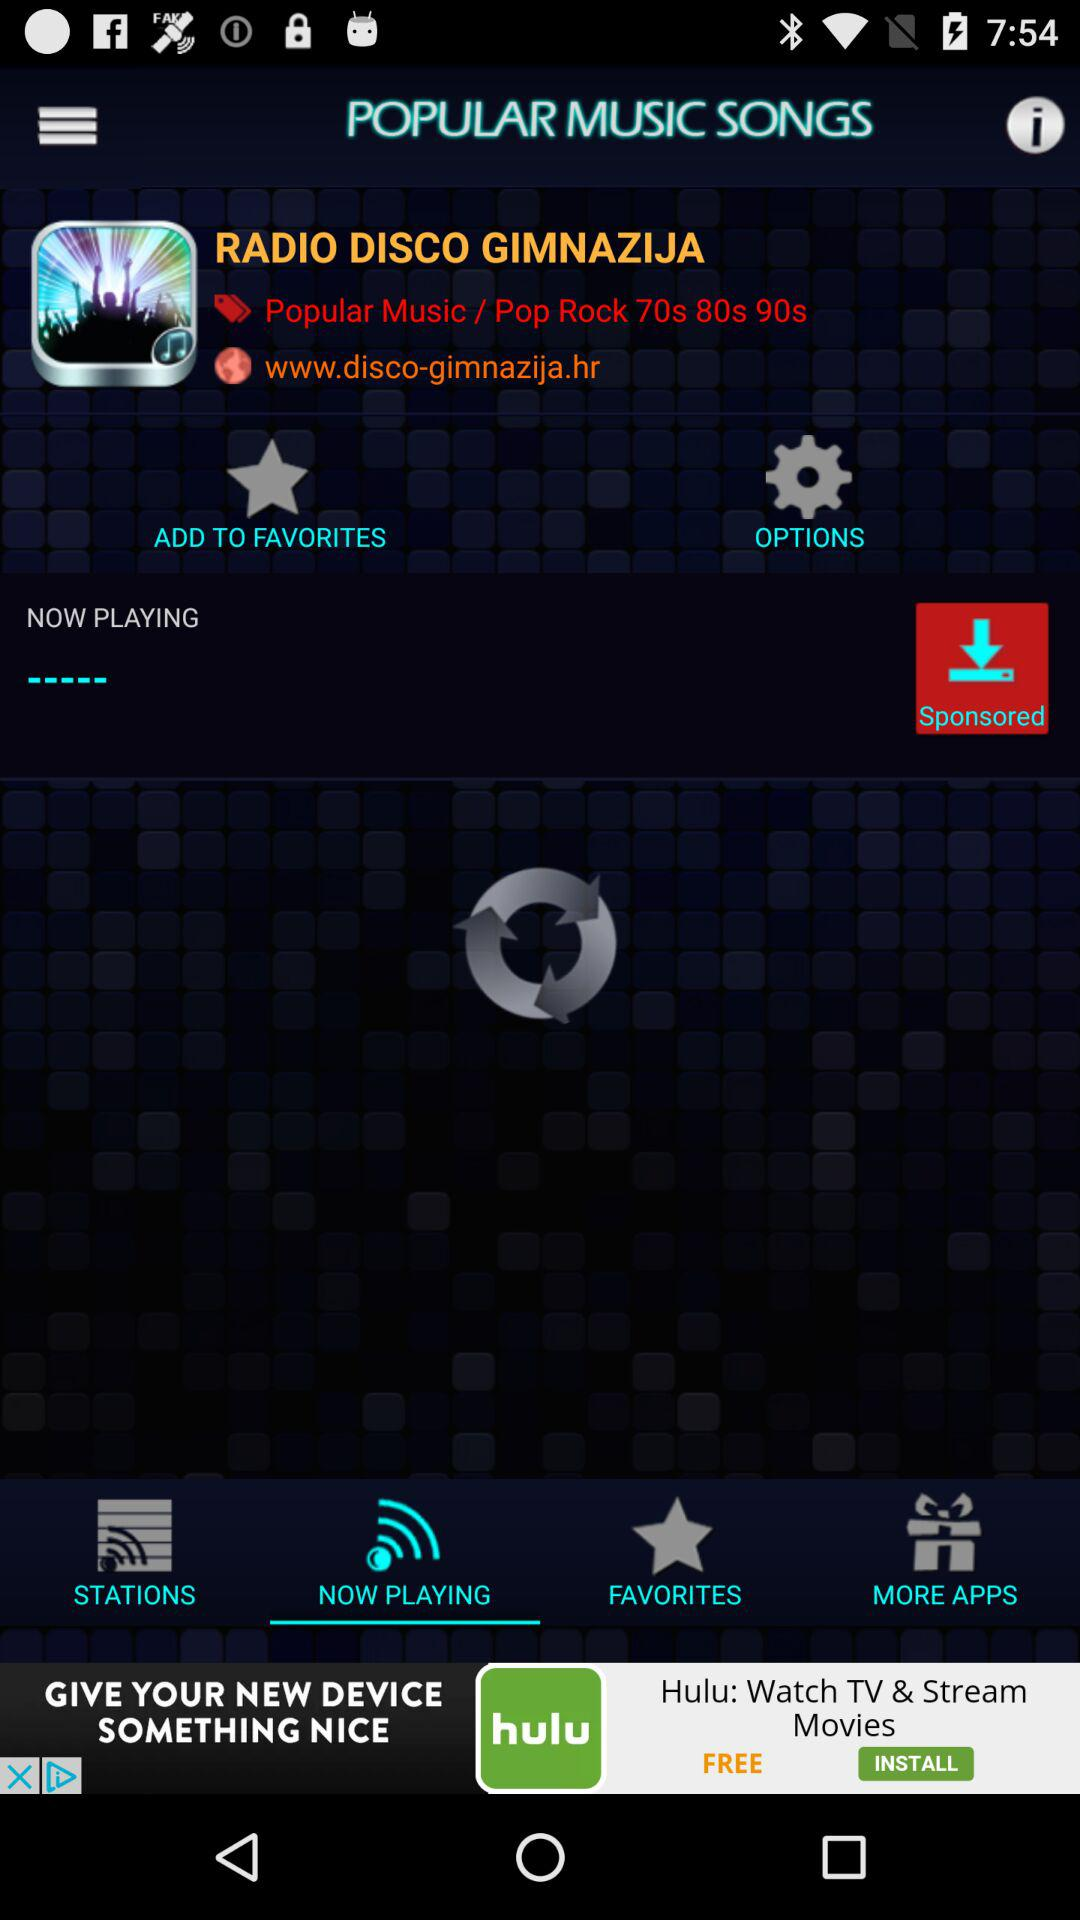What types of songs are available in "RADIO DISCO GIMNAZIJA"? The types of songs available in "RADIO DISCO GIMNAZIJA" are "Popular Music / Pop Rock 70s 80s 90s". 